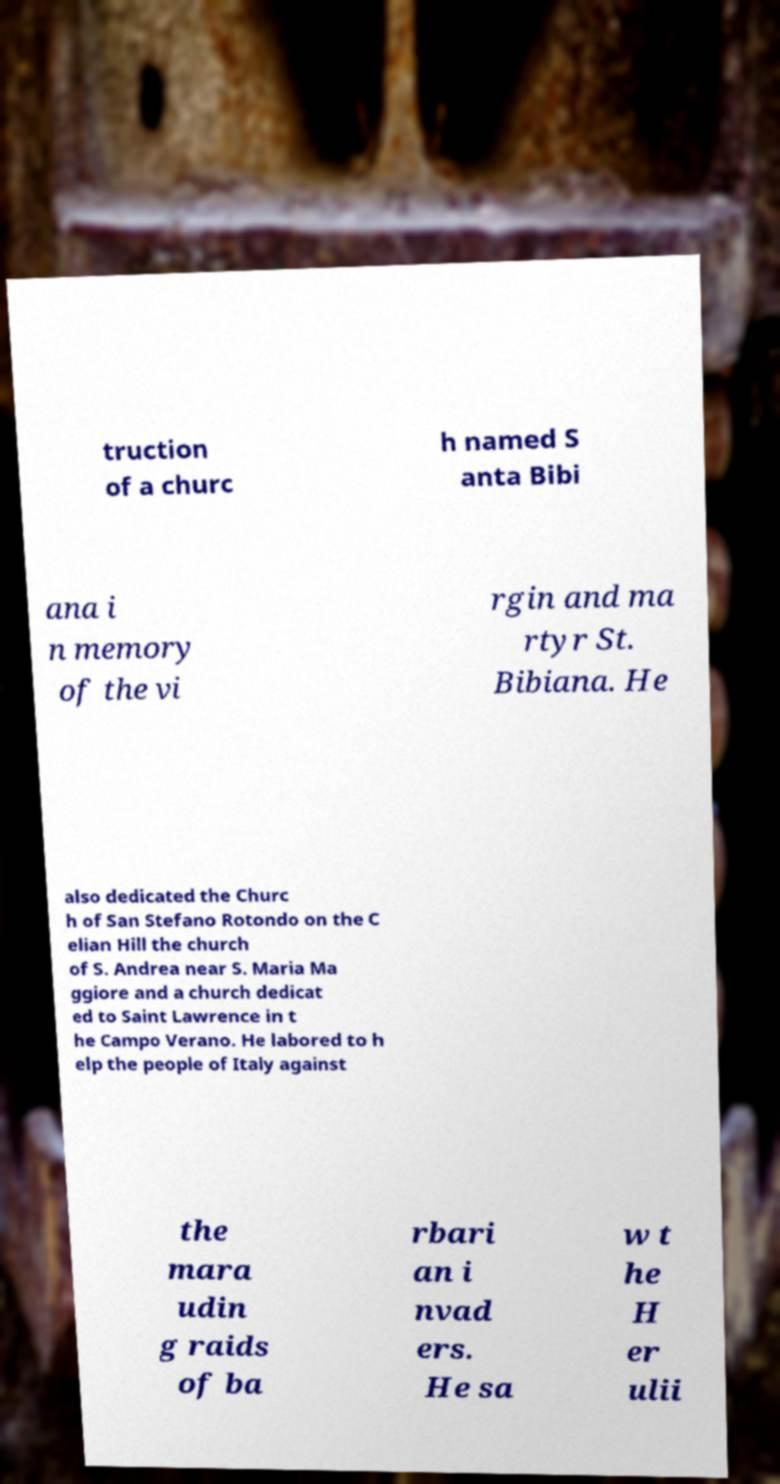Could you extract and type out the text from this image? truction of a churc h named S anta Bibi ana i n memory of the vi rgin and ma rtyr St. Bibiana. He also dedicated the Churc h of San Stefano Rotondo on the C elian Hill the church of S. Andrea near S. Maria Ma ggiore and a church dedicat ed to Saint Lawrence in t he Campo Verano. He labored to h elp the people of Italy against the mara udin g raids of ba rbari an i nvad ers. He sa w t he H er ulii 